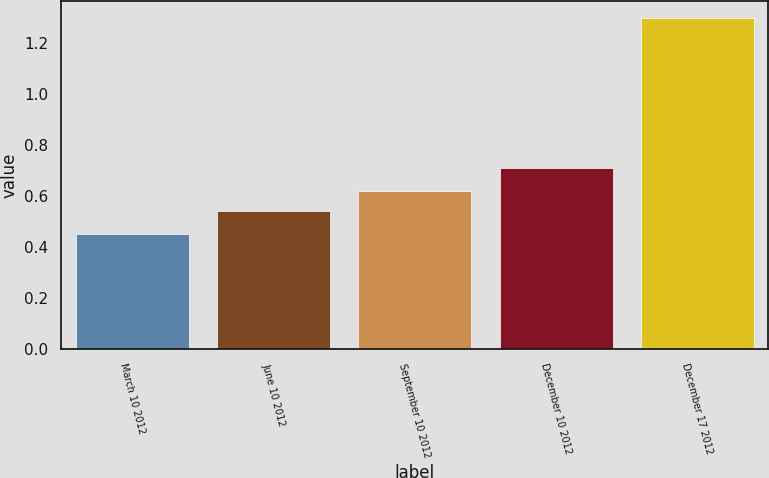<chart> <loc_0><loc_0><loc_500><loc_500><bar_chart><fcel>March 10 2012<fcel>June 10 2012<fcel>September 10 2012<fcel>December 10 2012<fcel>December 17 2012<nl><fcel>0.45<fcel>0.54<fcel>0.62<fcel>0.71<fcel>1.3<nl></chart> 